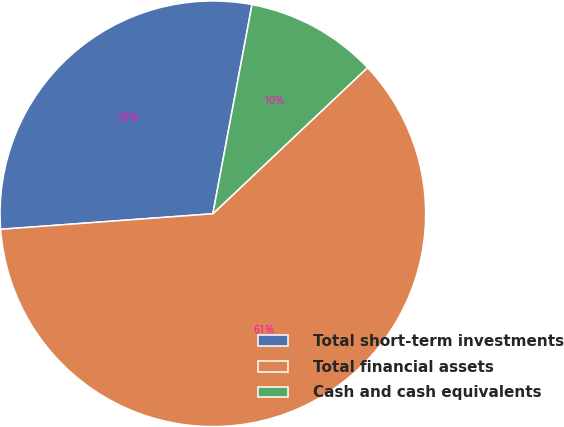<chart> <loc_0><loc_0><loc_500><loc_500><pie_chart><fcel>Total short-term investments<fcel>Total financial assets<fcel>Cash and cash equivalents<nl><fcel>29.11%<fcel>60.89%<fcel>10.0%<nl></chart> 